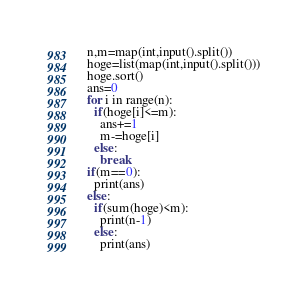Convert code to text. <code><loc_0><loc_0><loc_500><loc_500><_Python_>n,m=map(int,input().split())
hoge=list(map(int,input().split()))
hoge.sort()
ans=0
for i in range(n):
  if(hoge[i]<=m):
    ans+=1
    m-=hoge[i]
  else:
    break
if(m==0):
  print(ans)
else:
  if(sum(hoge)<m):
    print(n-1)
  else:
    print(ans)</code> 